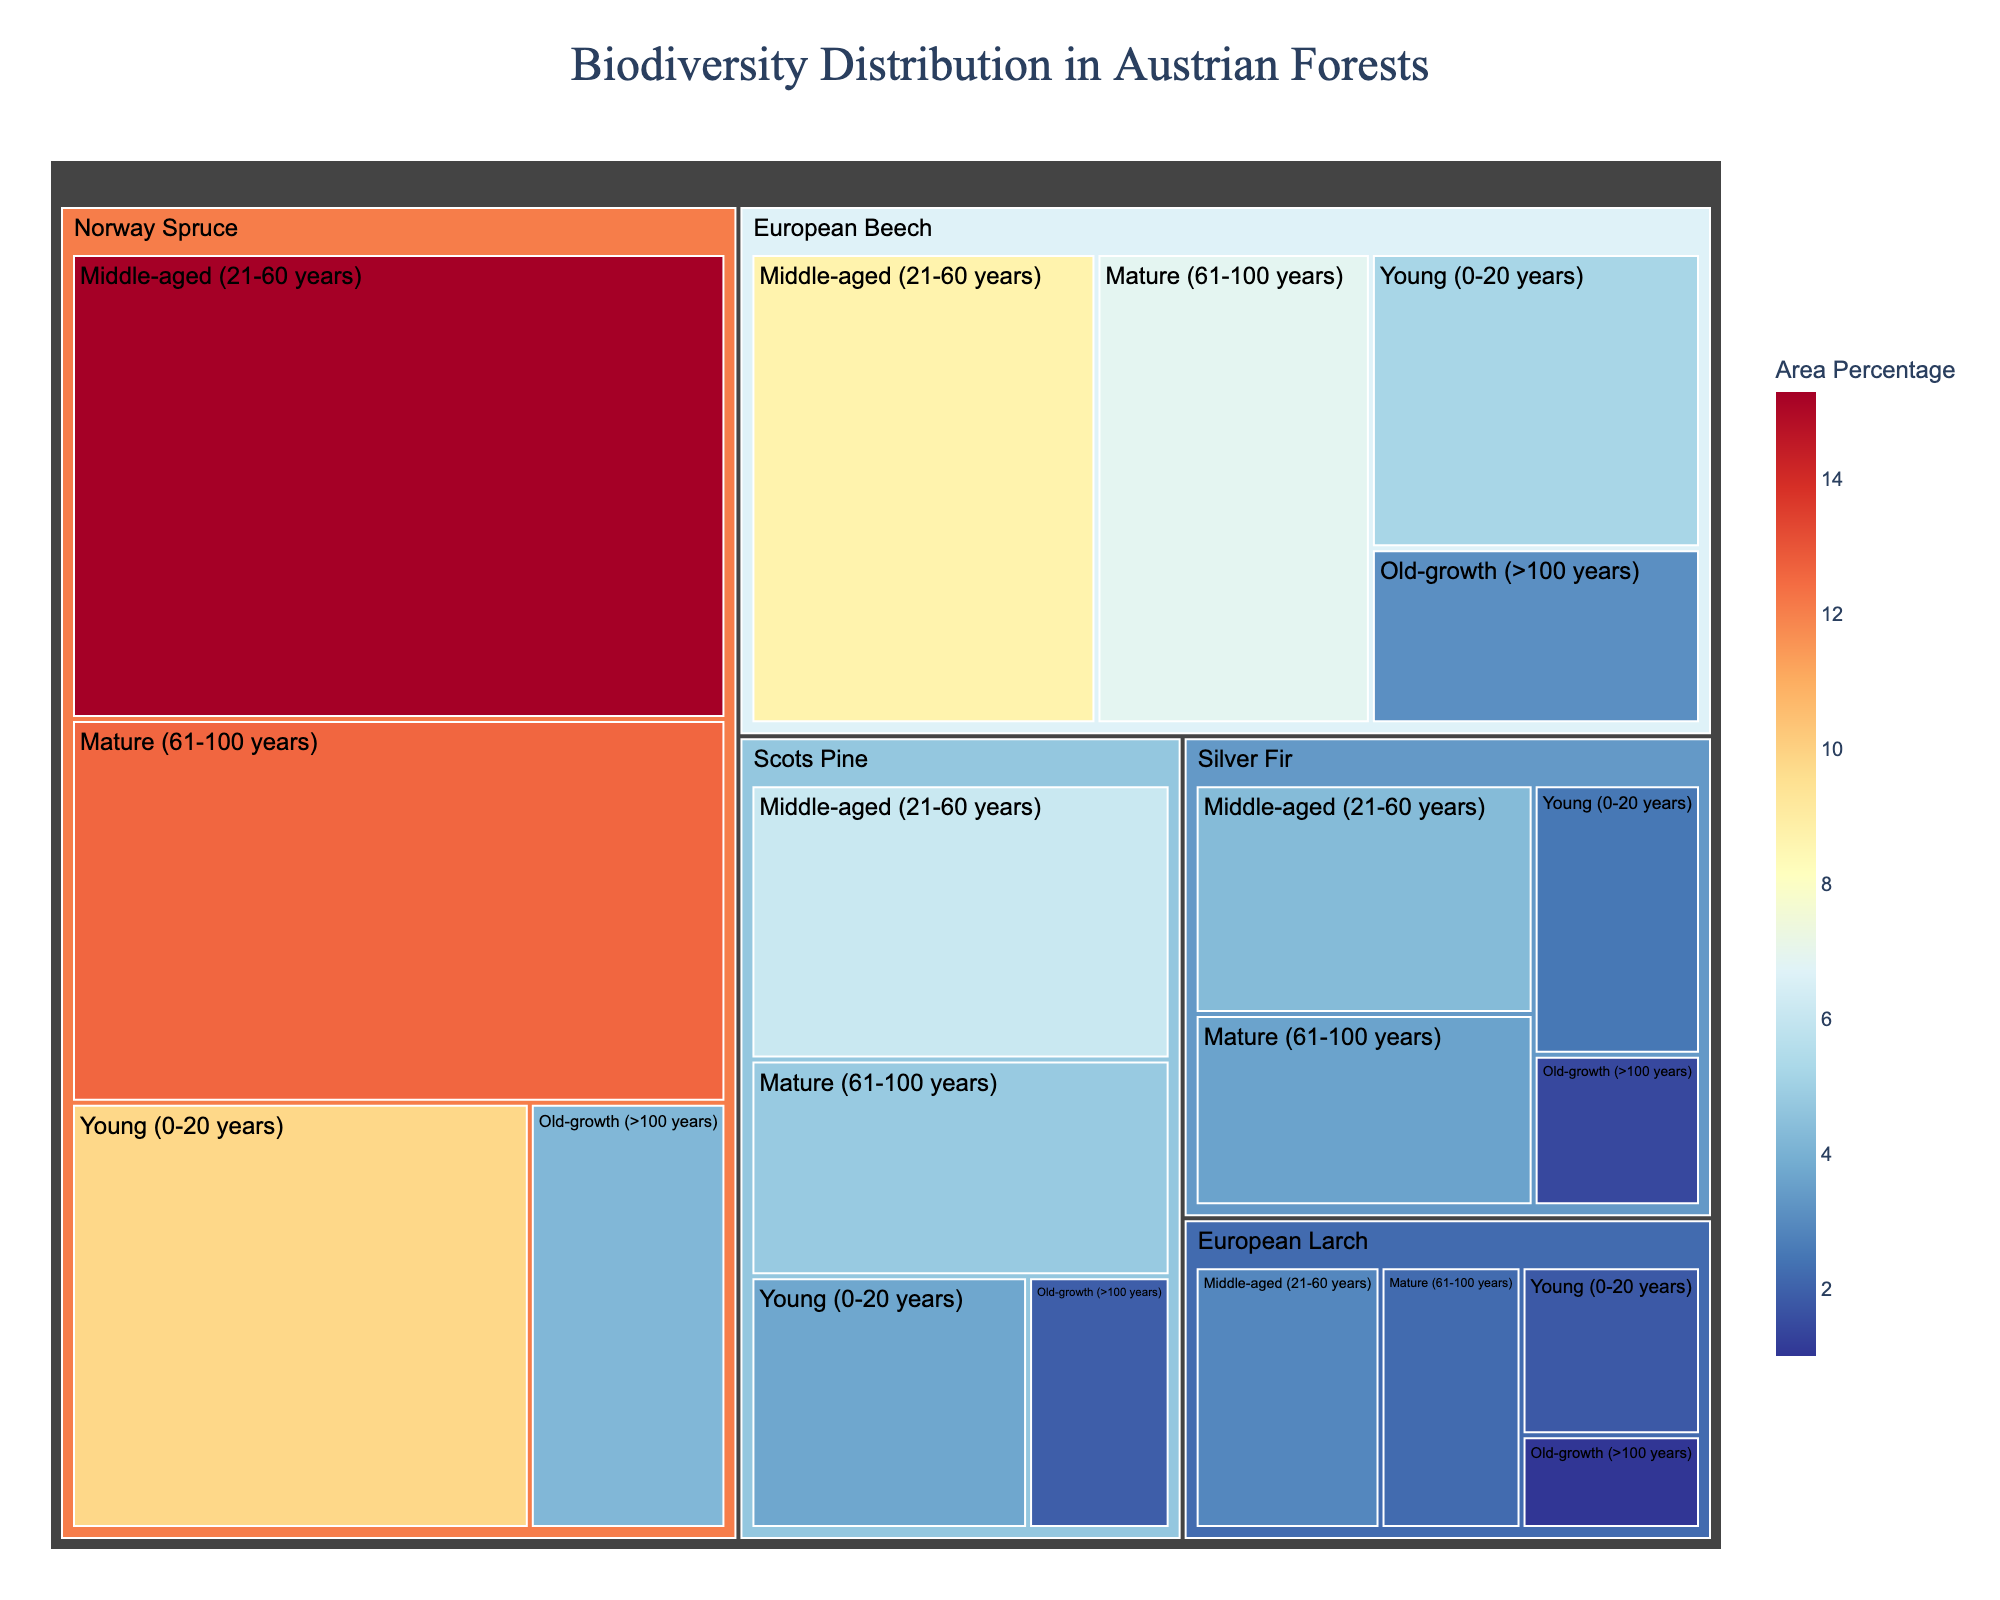What is the title of the treemap? Look at the text located at the top of the treemap, which indicates the title.
Answer: Biodiversity Distribution in Austrian Forests Which tree species has the highest area percentage in the young age group (0-20 years)? Locate the section for the "Young (0-20 years)" age group in the treemap and look for the species with the largest area percentage.
Answer: Norway Spruce What is the total area percentage for European Beech across all age groups? Add the area percentages for European Beech in all age groups: 5.2 (Young) + 8.7 (Middle-aged) + 6.9 (Mature) + 3.1 (Old-growth).
Answer: 23.9% Which age group has the smallest representation for Silver Fir? Identify the segments for Silver Fir and compare the area percentages across different age groups. The smallest area percentage is in the "Old-growth (>100 years)" group.
Answer: Old-growth (>100 years) Compare Norway Spruce and Scots Pine: which species has a higher area percentage in the middle-aged (21-60 years) group? Look at the area percentages for both Norway Spruce and Scots Pine in the "Middle-aged (21-60 years)" group and compare them. Norway Spruce has 15.3%, and Scots Pine has 6.1%.
Answer: Norway Spruce In which age group does European Larch have the highest area percentage? Locate the segments for European Larch and compare the area percentages across different age groups. The "Middle-aged (21-60 years)" group has the highest percentage.
Answer: Middle-aged (21-60 years) What is the combined area percentage of mature (61-100 years) forests for all species? Sum the area percentages for all species in the "Mature (61-100 years)" age group: 6.9 (European Beech) + 12.6 (Norway Spruce) + 4.8 (Scots Pine) + 3.6 (Silver Fir) + 2.2 (European Larch).
Answer: 30.1% Between European Beech and Silver Fir, which tree species has a larger area percentage in the old-growth (>100 years) age group? Compare the area percentages for European Beech and Silver Fir in the "Old-growth (>100 years)" age group. European Beech has 3.1%, and Silver Fir has 1.4%.
Answer: European Beech What is the difference in area percentage between the largest (Norway Spruce) and smallest (European Larch) species in the young (0-20 years) age group? Find the area percentages for Norway Spruce (9.8%) and European Larch (1.8%) in the "Young (0-20 years)" group and calculate the difference. 9.8 - 1.8 = 8.0.
Answer: 8.0% How does the biodiversity distribution change from young (0-20 years) to old-growth (>100 years) for Norway Spruce? Compare the area percentages for Norway Spruce in the "Young (0-20 years)" (9.8%) and "Old-growth (>100 years)" (4.2%) age groups to see the trend.
Answer: Decreases from 9.8% to 4.2% 